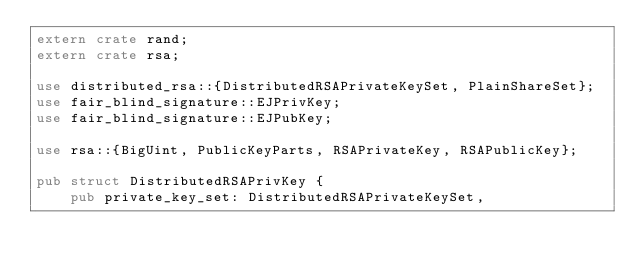<code> <loc_0><loc_0><loc_500><loc_500><_Rust_>extern crate rand;
extern crate rsa;

use distributed_rsa::{DistributedRSAPrivateKeySet, PlainShareSet};
use fair_blind_signature::EJPrivKey;
use fair_blind_signature::EJPubKey;

use rsa::{BigUint, PublicKeyParts, RSAPrivateKey, RSAPublicKey};

pub struct DistributedRSAPrivKey {
    pub private_key_set: DistributedRSAPrivateKeySet,</code> 